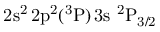Convert formula to latex. <formula><loc_0><loc_0><loc_500><loc_500>2 s ^ { 2 } \, 2 p ^ { 2 } ( ^ { 3 } P ) \, 3 s ^ { 2 } P _ { 3 / 2 }</formula> 